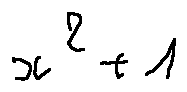<formula> <loc_0><loc_0><loc_500><loc_500>x ^ { 2 } + 1</formula> 